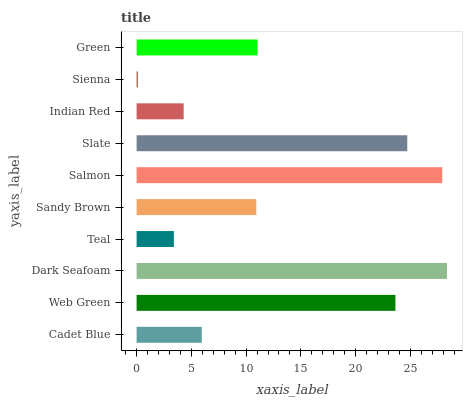Is Sienna the minimum?
Answer yes or no. Yes. Is Dark Seafoam the maximum?
Answer yes or no. Yes. Is Web Green the minimum?
Answer yes or no. No. Is Web Green the maximum?
Answer yes or no. No. Is Web Green greater than Cadet Blue?
Answer yes or no. Yes. Is Cadet Blue less than Web Green?
Answer yes or no. Yes. Is Cadet Blue greater than Web Green?
Answer yes or no. No. Is Web Green less than Cadet Blue?
Answer yes or no. No. Is Green the high median?
Answer yes or no. Yes. Is Sandy Brown the low median?
Answer yes or no. Yes. Is Web Green the high median?
Answer yes or no. No. Is Dark Seafoam the low median?
Answer yes or no. No. 